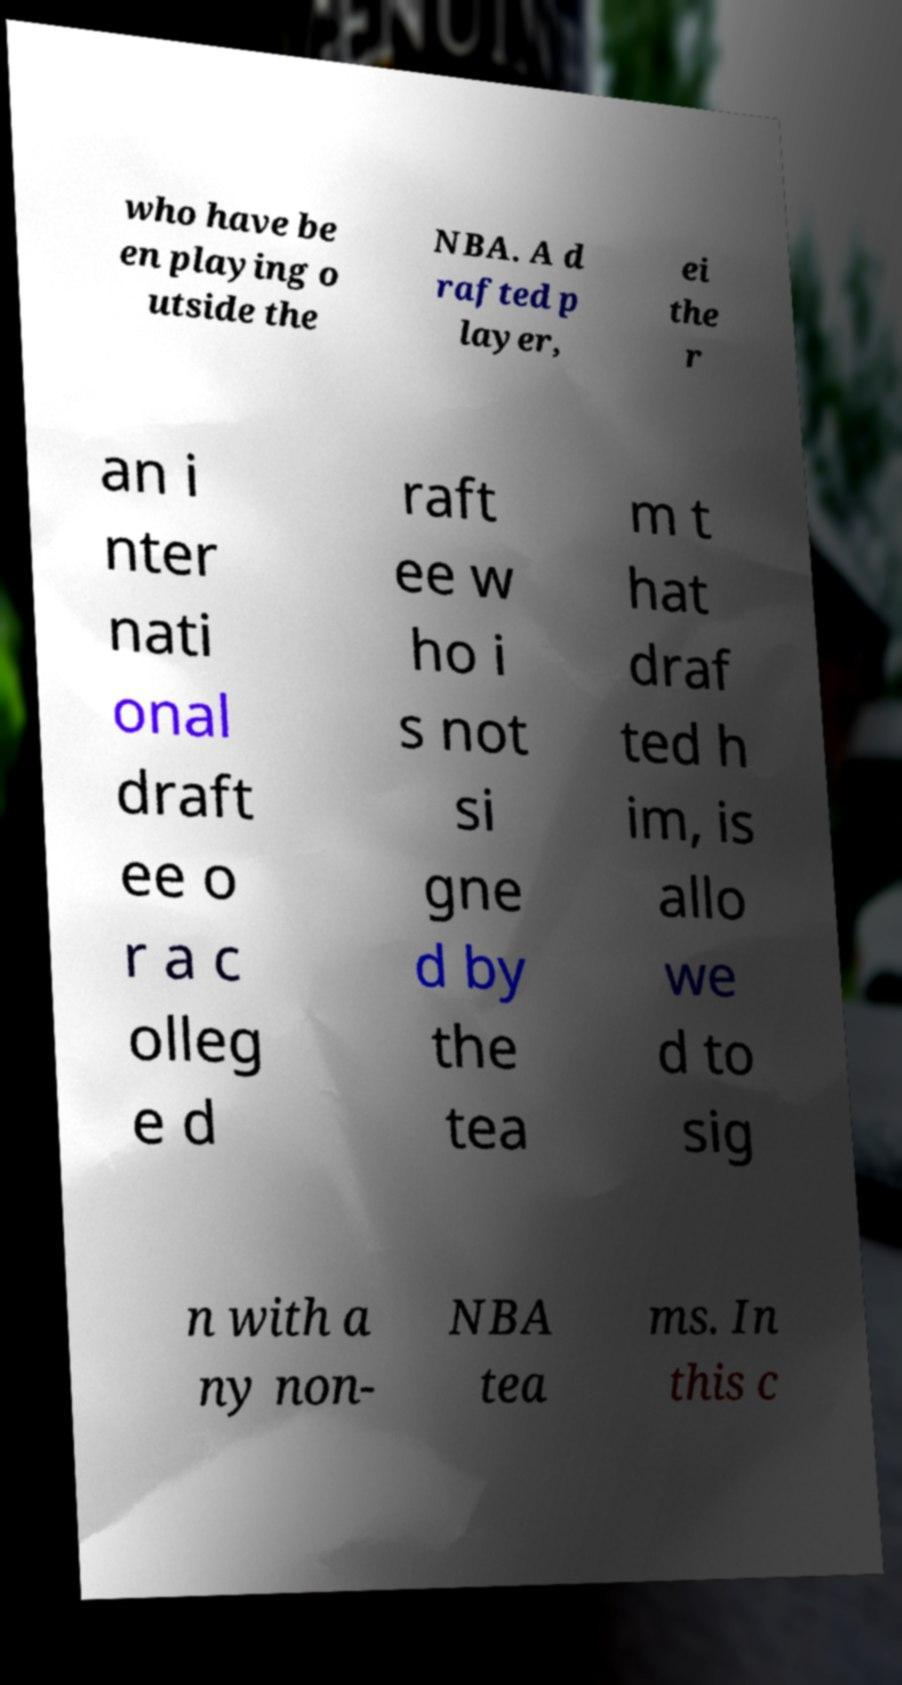Could you assist in decoding the text presented in this image and type it out clearly? who have be en playing o utside the NBA. A d rafted p layer, ei the r an i nter nati onal draft ee o r a c olleg e d raft ee w ho i s not si gne d by the tea m t hat draf ted h im, is allo we d to sig n with a ny non- NBA tea ms. In this c 